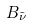<formula> <loc_0><loc_0><loc_500><loc_500>B _ { \tilde { \nu } }</formula> 